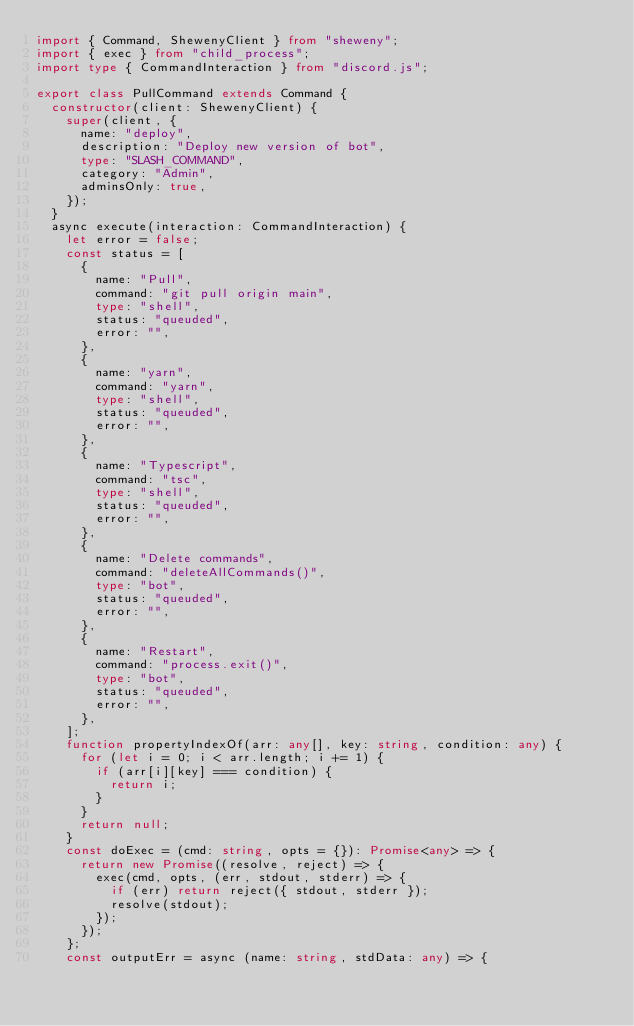Convert code to text. <code><loc_0><loc_0><loc_500><loc_500><_TypeScript_>import { Command, ShewenyClient } from "sheweny";
import { exec } from "child_process";
import type { CommandInteraction } from "discord.js";

export class PullCommand extends Command {
  constructor(client: ShewenyClient) {
    super(client, {
      name: "deploy",
      description: "Deploy new version of bot",
      type: "SLASH_COMMAND",
      category: "Admin",
      adminsOnly: true,
    });
  }
  async execute(interaction: CommandInteraction) {
    let error = false;
    const status = [
      {
        name: "Pull",
        command: "git pull origin main",
        type: "shell",
        status: "queuded",
        error: "",
      },
      {
        name: "yarn",
        command: "yarn",
        type: "shell",
        status: "queuded",
        error: "",
      },
      {
        name: "Typescript",
        command: "tsc",
        type: "shell",
        status: "queuded",
        error: "",
      },
      {
        name: "Delete commands",
        command: "deleteAllCommands()",
        type: "bot",
        status: "queuded",
        error: "",
      },
      {
        name: "Restart",
        command: "process.exit()",
        type: "bot",
        status: "queuded",
        error: "",
      },
    ];
    function propertyIndexOf(arr: any[], key: string, condition: any) {
      for (let i = 0; i < arr.length; i += 1) {
        if (arr[i][key] === condition) {
          return i;
        }
      }
      return null;
    }
    const doExec = (cmd: string, opts = {}): Promise<any> => {
      return new Promise((resolve, reject) => {
        exec(cmd, opts, (err, stdout, stderr) => {
          if (err) return reject({ stdout, stderr });
          resolve(stdout);
        });
      });
    };
    const outputErr = async (name: string, stdData: any) => {</code> 